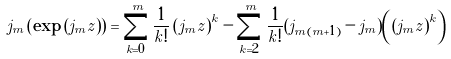<formula> <loc_0><loc_0><loc_500><loc_500>j _ { m } \left ( \exp \left ( j _ { m } z \right ) \right ) = \sum _ { k = 0 } ^ { m } \frac { 1 } { k ! } \left ( j _ { m } z \right ) ^ { k } - \sum _ { k = 2 } ^ { m } \frac { 1 } { k ! } ( j _ { m ( m + 1 ) } - j _ { m } ) \left ( \left ( j _ { m } z \right ) ^ { k } \right )</formula> 